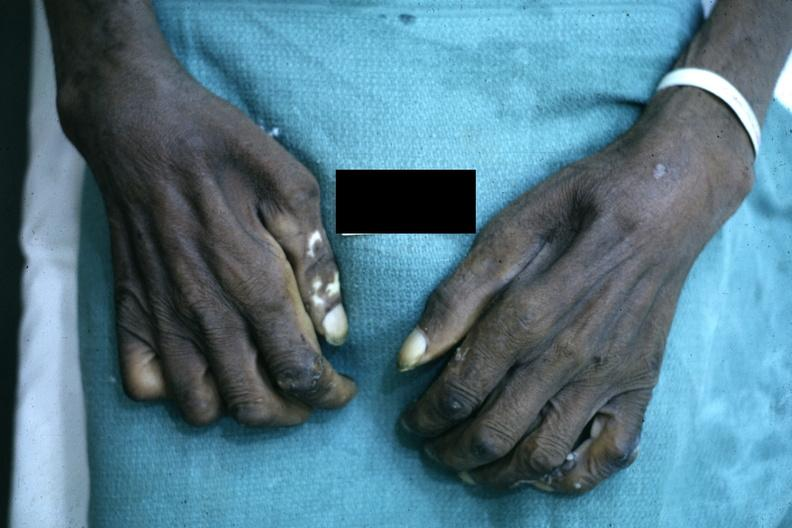s hand present?
Answer the question using a single word or phrase. Yes 